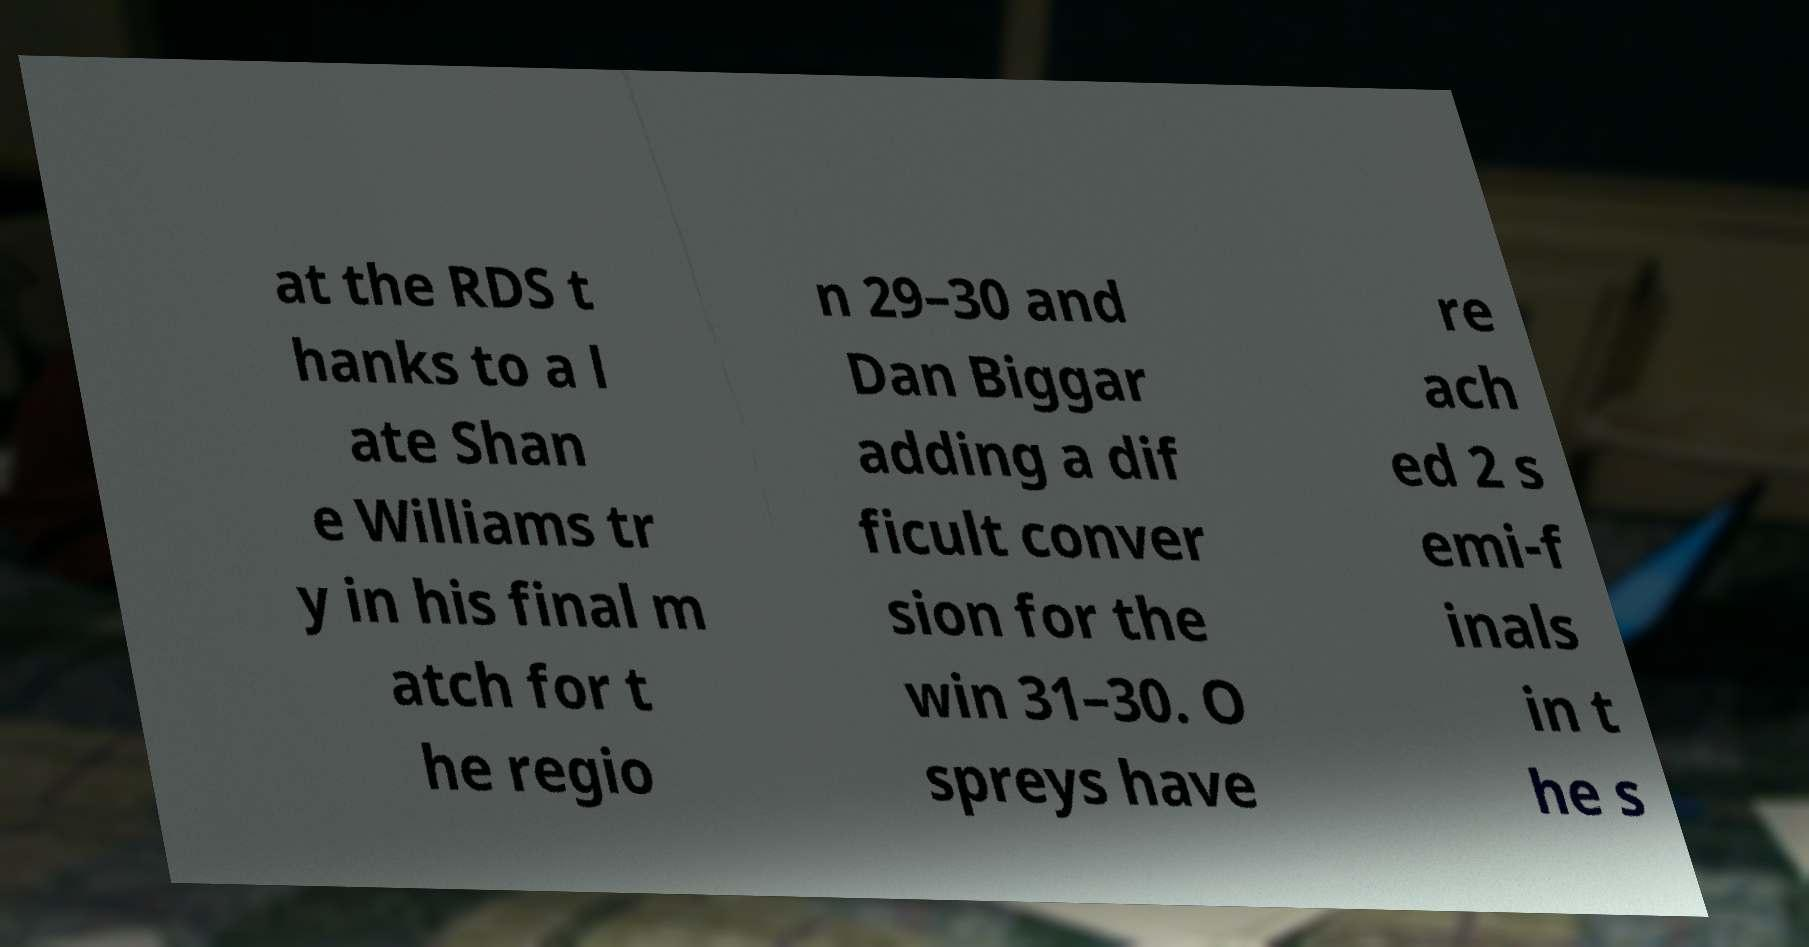Could you extract and type out the text from this image? at the RDS t hanks to a l ate Shan e Williams tr y in his final m atch for t he regio n 29–30 and Dan Biggar adding a dif ficult conver sion for the win 31–30. O spreys have re ach ed 2 s emi-f inals in t he s 